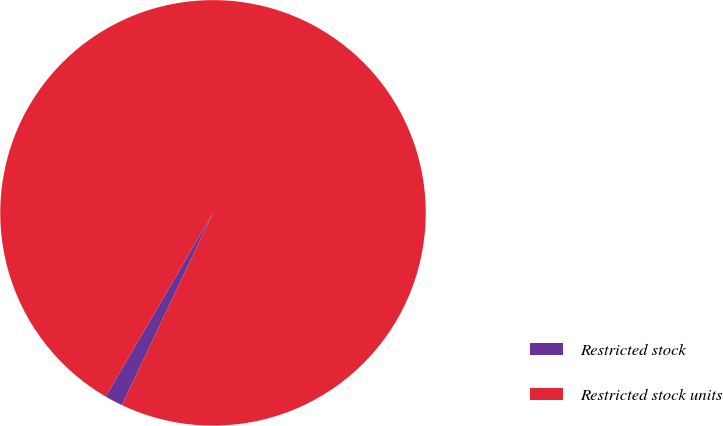Convert chart to OTSL. <chart><loc_0><loc_0><loc_500><loc_500><pie_chart><fcel>Restricted stock<fcel>Restricted stock units<nl><fcel>1.37%<fcel>98.63%<nl></chart> 